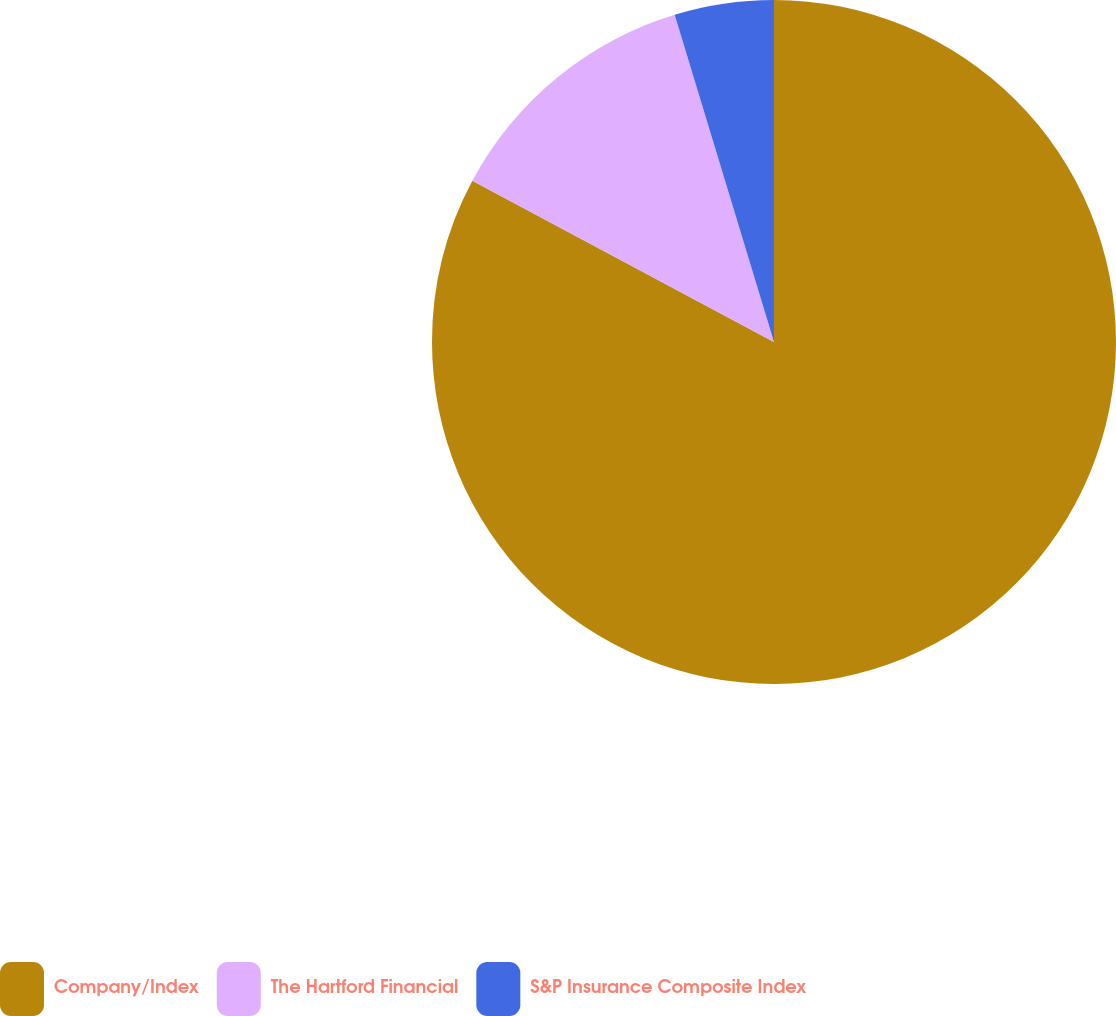Convert chart. <chart><loc_0><loc_0><loc_500><loc_500><pie_chart><fcel>Company/Index<fcel>The Hartford Financial<fcel>S&P Insurance Composite Index<nl><fcel>82.8%<fcel>12.5%<fcel>4.69%<nl></chart> 